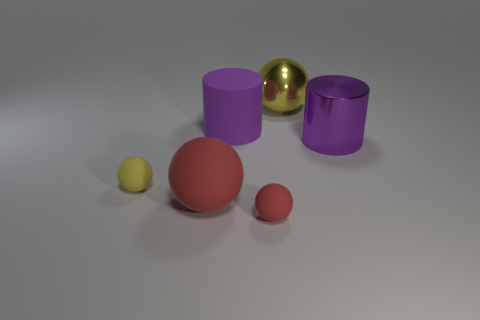Add 3 large cylinders. How many objects exist? 9 Subtract all cylinders. How many objects are left? 4 Add 6 large purple metal objects. How many large purple metal objects exist? 7 Subtract 2 purple cylinders. How many objects are left? 4 Subtract all big shiny things. Subtract all big yellow things. How many objects are left? 3 Add 4 large shiny cylinders. How many large shiny cylinders are left? 5 